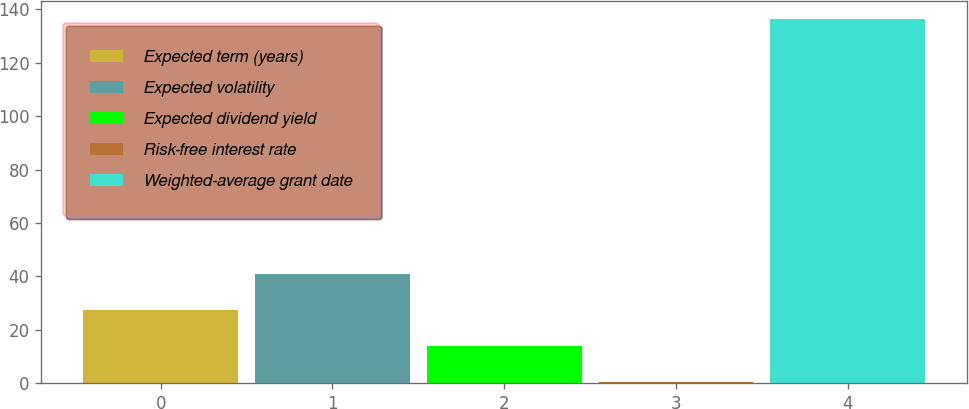Convert chart. <chart><loc_0><loc_0><loc_500><loc_500><bar_chart><fcel>Expected term (years)<fcel>Expected volatility<fcel>Expected dividend yield<fcel>Risk-free interest rate<fcel>Weighted-average grant date<nl><fcel>27.48<fcel>41.07<fcel>13.89<fcel>0.3<fcel>136.16<nl></chart> 